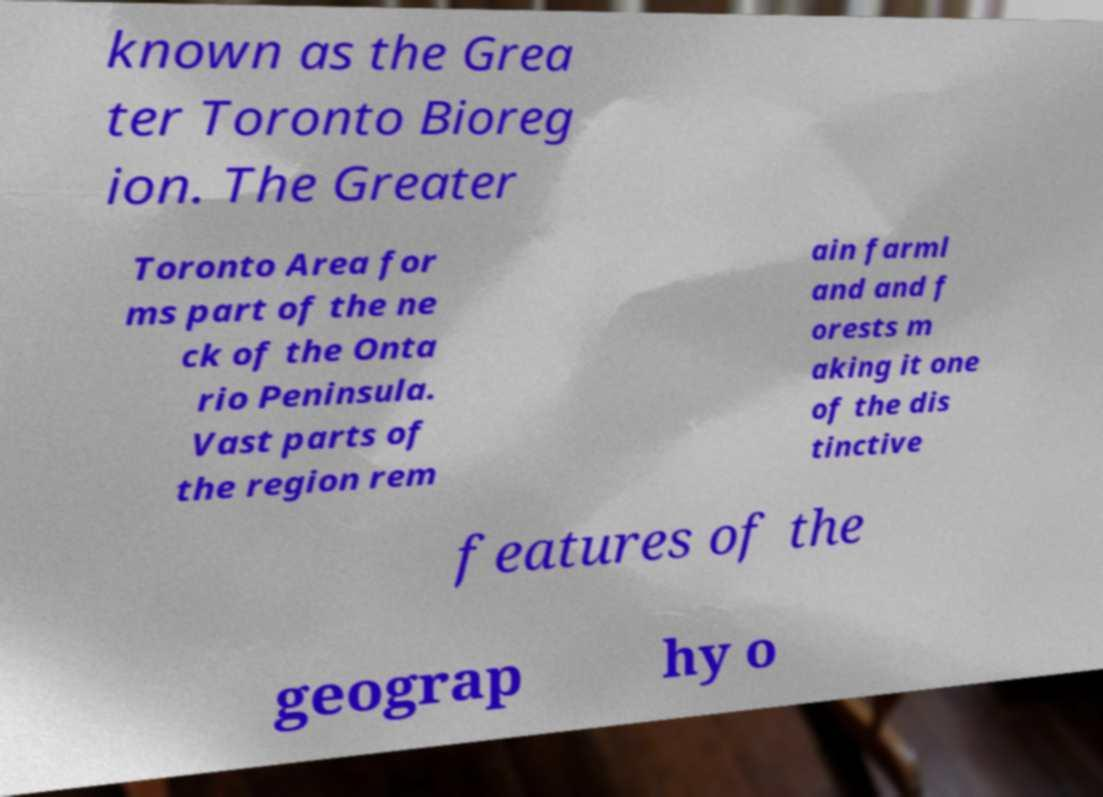For documentation purposes, I need the text within this image transcribed. Could you provide that? known as the Grea ter Toronto Bioreg ion. The Greater Toronto Area for ms part of the ne ck of the Onta rio Peninsula. Vast parts of the region rem ain farml and and f orests m aking it one of the dis tinctive features of the geograp hy o 